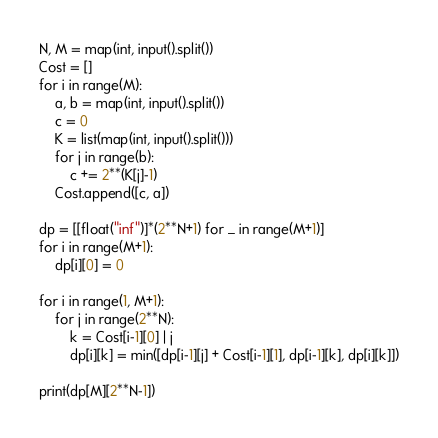<code> <loc_0><loc_0><loc_500><loc_500><_Python_>N, M = map(int, input().split())
Cost = []
for i in range(M):
    a, b = map(int, input().split())
    c = 0
    K = list(map(int, input().split()))
    for j in range(b):
        c += 2**(K[j]-1)
    Cost.append([c, a])

dp = [[float("inf")]*(2**N+1) for _ in range(M+1)]
for i in range(M+1):
    dp[i][0] = 0

for i in range(1, M+1):
    for j in range(2**N):
        k = Cost[i-1][0] | j
        dp[i][k] = min([dp[i-1][j] + Cost[i-1][1], dp[i-1][k], dp[i][k]])

print(dp[M][2**N-1])</code> 